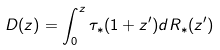Convert formula to latex. <formula><loc_0><loc_0><loc_500><loc_500>D ( z ) = \int ^ { z } _ { 0 } \tau _ { * } ( 1 + z ^ { \prime } ) d R _ { * } ( z ^ { \prime } )</formula> 